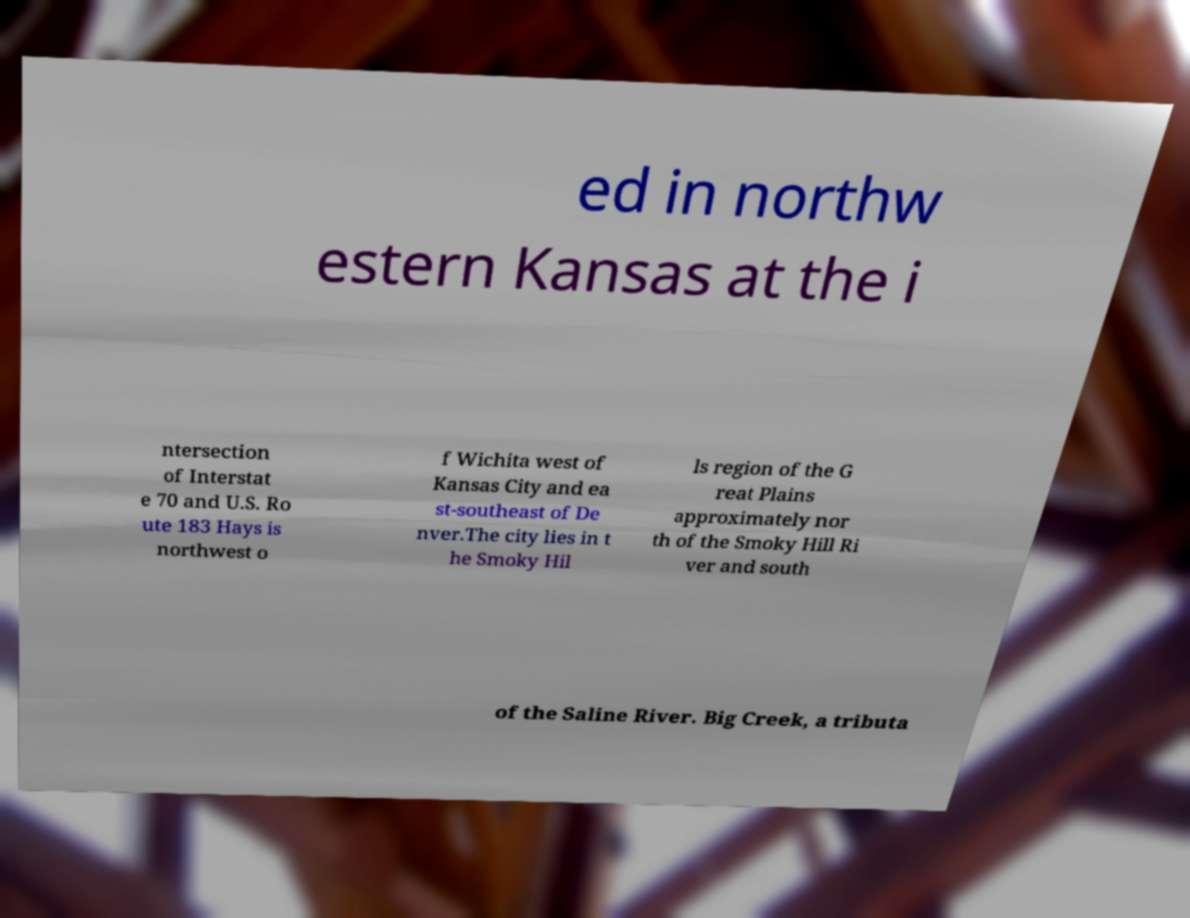Could you extract and type out the text from this image? ed in northw estern Kansas at the i ntersection of Interstat e 70 and U.S. Ro ute 183 Hays is northwest o f Wichita west of Kansas City and ea st-southeast of De nver.The city lies in t he Smoky Hil ls region of the G reat Plains approximately nor th of the Smoky Hill Ri ver and south of the Saline River. Big Creek, a tributa 